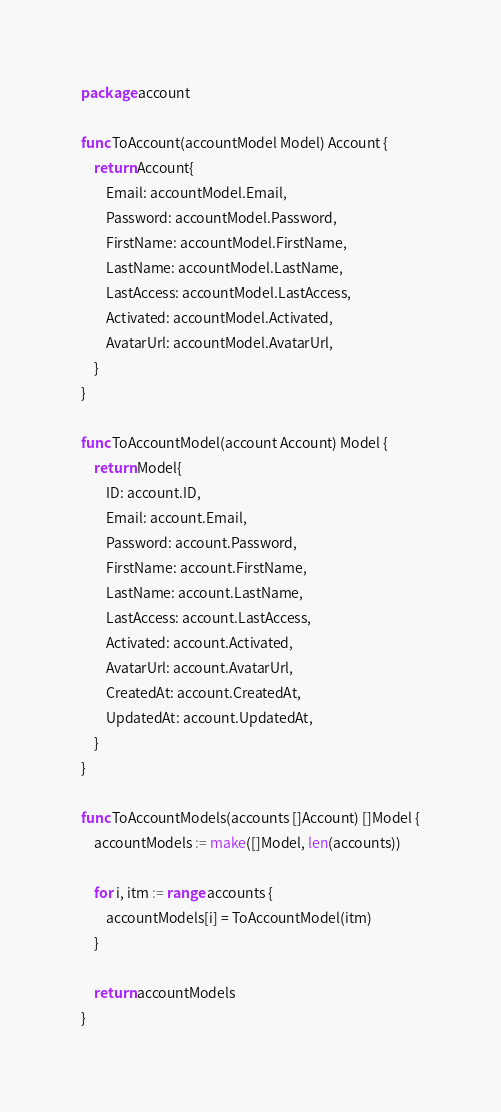Convert code to text. <code><loc_0><loc_0><loc_500><loc_500><_Go_>package account

func ToAccount(accountModel Model) Account {
	return Account{
		Email: accountModel.Email,
		Password: accountModel.Password,
		FirstName: accountModel.FirstName,
		LastName: accountModel.LastName,
		LastAccess: accountModel.LastAccess,
		Activated: accountModel.Activated,
		AvatarUrl: accountModel.AvatarUrl,
	}
}

func ToAccountModel(account Account) Model {
	return Model{
		ID: account.ID,
		Email: account.Email,
		Password: account.Password,
		FirstName: account.FirstName,
		LastName: account.LastName,
		LastAccess: account.LastAccess,
		Activated: account.Activated,
		AvatarUrl: account.AvatarUrl,
		CreatedAt: account.CreatedAt,
		UpdatedAt: account.UpdatedAt,
	}
}

func ToAccountModels(accounts []Account) []Model {
	accountModels := make([]Model, len(accounts))

	for i, itm := range accounts {
		accountModels[i] = ToAccountModel(itm)
	}

	return accountModels
}</code> 